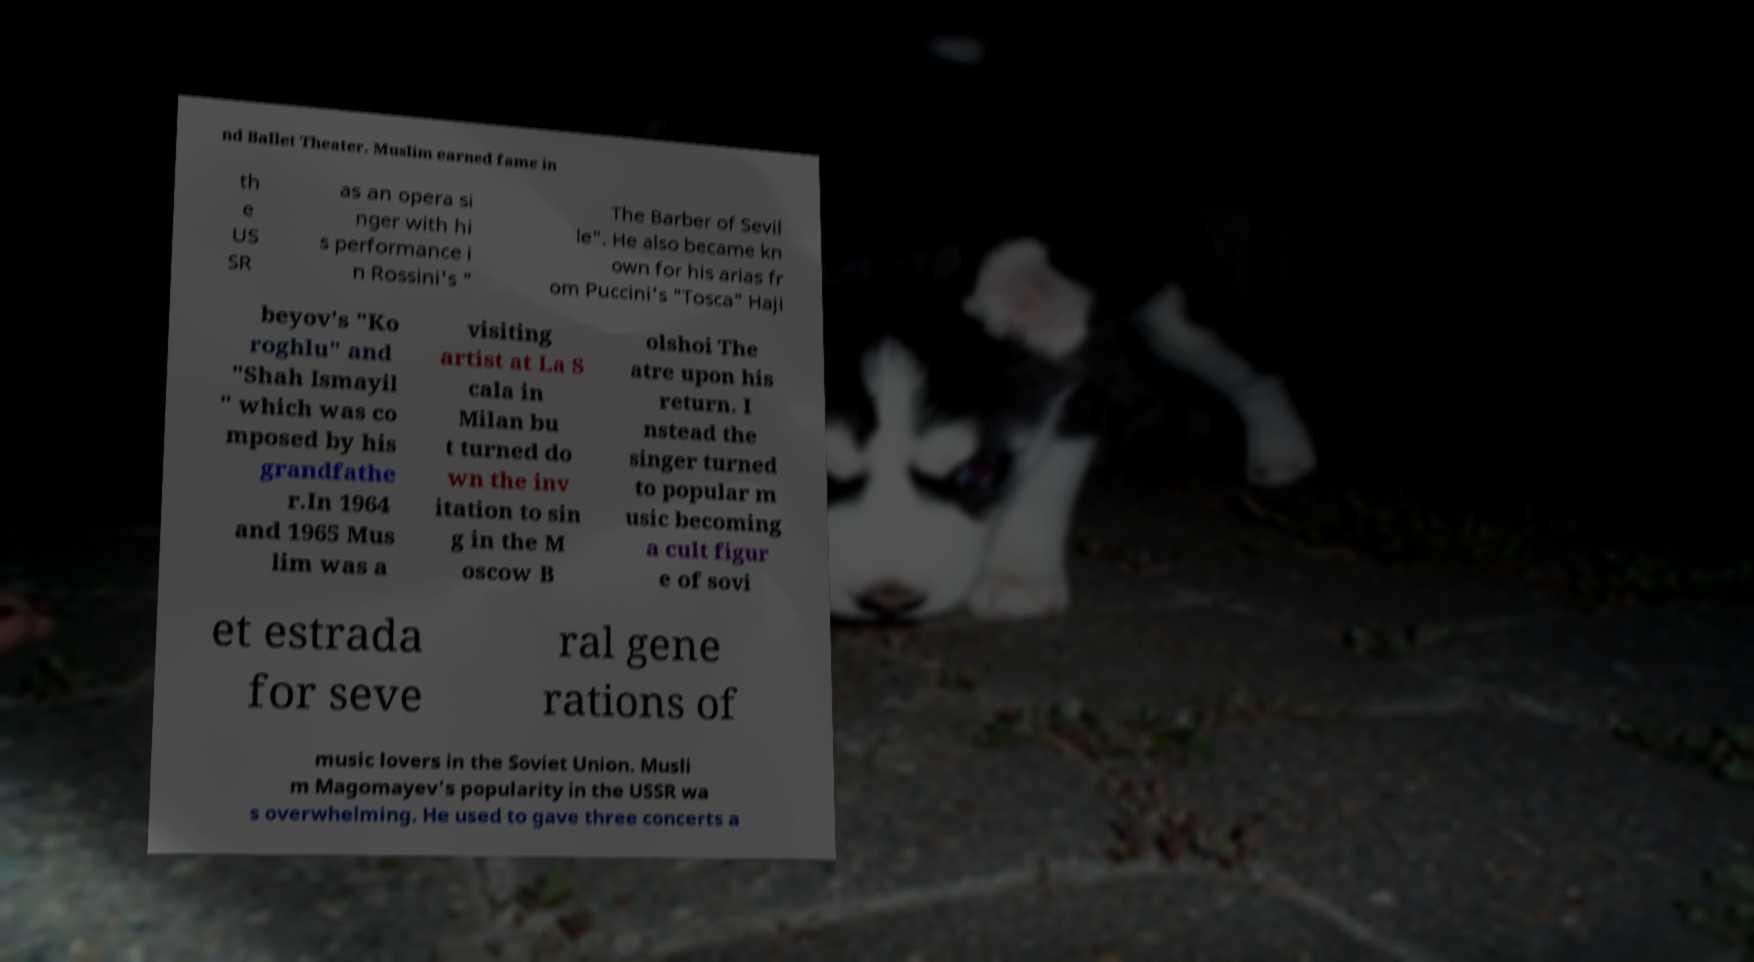What messages or text are displayed in this image? I need them in a readable, typed format. nd Ballet Theater. Muslim earned fame in th e US SR as an opera si nger with hi s performance i n Rossini's " The Barber of Sevil le". He also became kn own for his arias fr om Puccini's "Tosca" Haji beyov's "Ko roghlu" and "Shah Ismayil " which was co mposed by his grandfathe r.In 1964 and 1965 Mus lim was a visiting artist at La S cala in Milan bu t turned do wn the inv itation to sin g in the M oscow B olshoi The atre upon his return. I nstead the singer turned to popular m usic becoming a cult figur e of sovi et estrada for seve ral gene rations of music lovers in the Soviet Union. Musli m Magomayev's popularity in the USSR wa s overwhelming. He used to gave three concerts a 